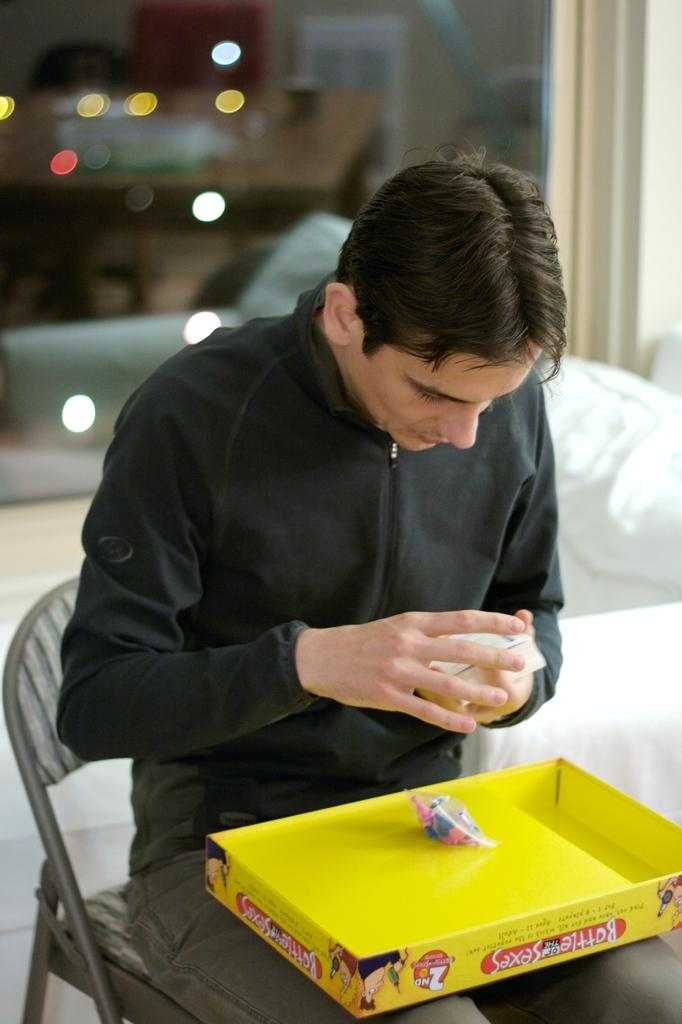What is the main subject of the image? There is a person in the image. What is the person doing in the image? The person is sitting on a chair. What is the person holding in his hand? The person is holding cards in his hand. What type of ball is the person kicking in the image? There is no ball present in the image; the person is holding cards in his hand. Are there any police officers visible in the image? There is no mention of police officers in the provided facts about the image. 